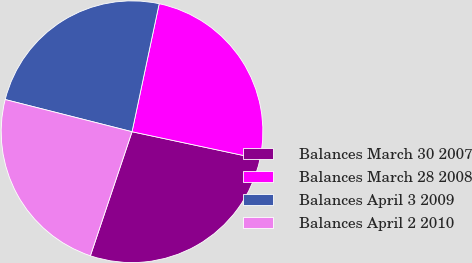Convert chart. <chart><loc_0><loc_0><loc_500><loc_500><pie_chart><fcel>Balances March 30 2007<fcel>Balances March 28 2008<fcel>Balances April 3 2009<fcel>Balances April 2 2010<nl><fcel>26.81%<fcel>25.02%<fcel>24.37%<fcel>23.8%<nl></chart> 